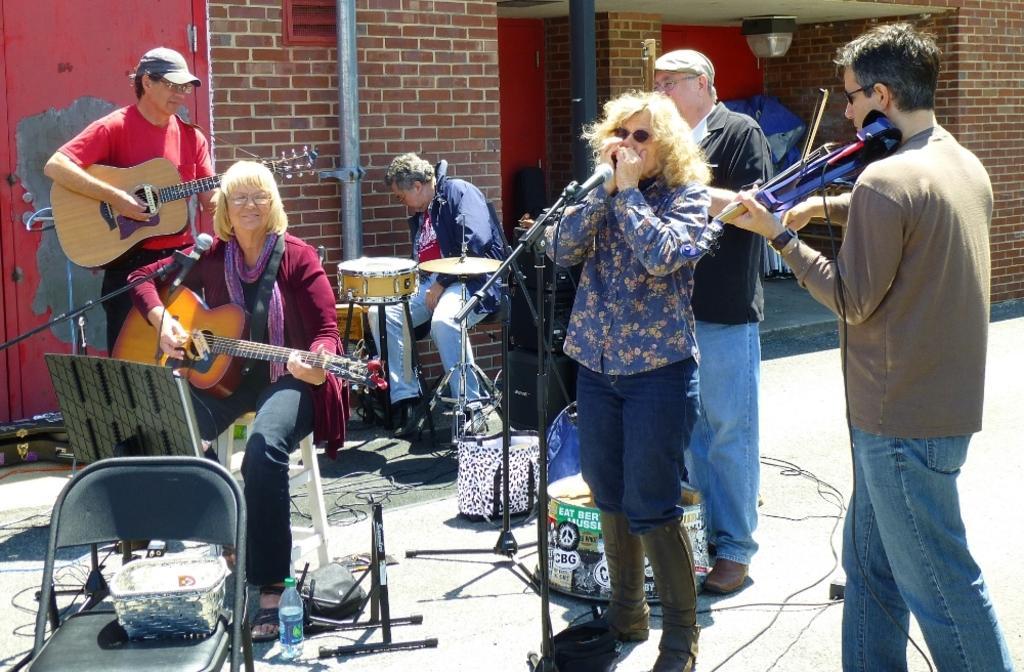In one or two sentences, can you explain what this image depicts? A band of musicians are performing on a footpath. 